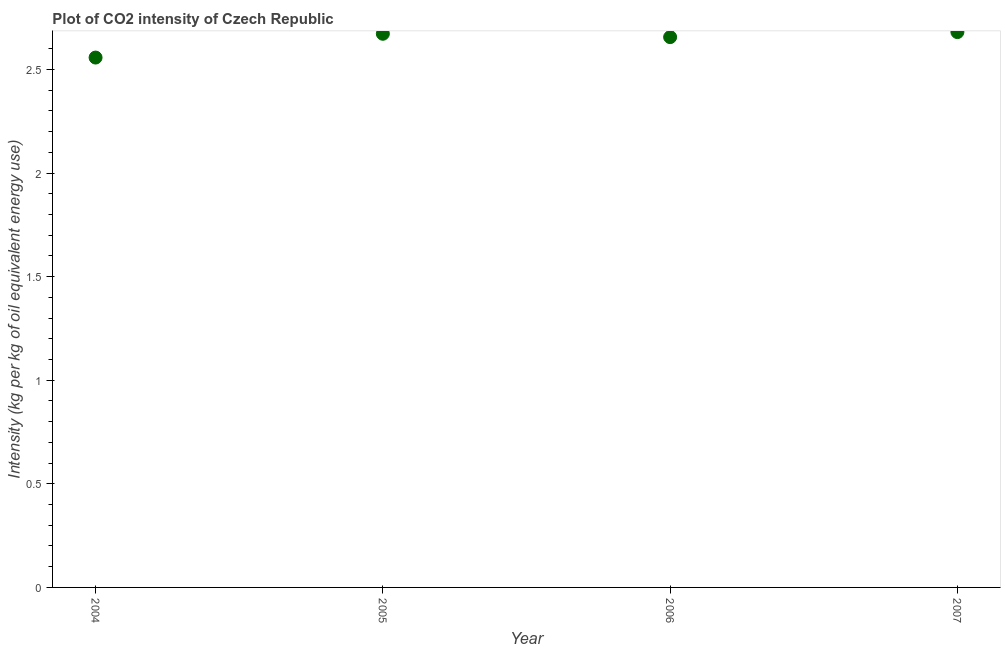What is the co2 intensity in 2004?
Your response must be concise. 2.56. Across all years, what is the maximum co2 intensity?
Your answer should be compact. 2.68. Across all years, what is the minimum co2 intensity?
Provide a short and direct response. 2.56. In which year was the co2 intensity minimum?
Give a very brief answer. 2004. What is the sum of the co2 intensity?
Give a very brief answer. 10.57. What is the difference between the co2 intensity in 2004 and 2007?
Keep it short and to the point. -0.12. What is the average co2 intensity per year?
Ensure brevity in your answer.  2.64. What is the median co2 intensity?
Provide a succinct answer. 2.66. In how many years, is the co2 intensity greater than 1.3 kg?
Your response must be concise. 4. Do a majority of the years between 2004 and 2006 (inclusive) have co2 intensity greater than 1.1 kg?
Your answer should be compact. Yes. What is the ratio of the co2 intensity in 2005 to that in 2006?
Offer a very short reply. 1.01. Is the co2 intensity in 2005 less than that in 2007?
Your answer should be very brief. Yes. What is the difference between the highest and the second highest co2 intensity?
Offer a terse response. 0.01. What is the difference between the highest and the lowest co2 intensity?
Provide a succinct answer. 0.12. How many dotlines are there?
Offer a very short reply. 1. How many years are there in the graph?
Offer a terse response. 4. What is the difference between two consecutive major ticks on the Y-axis?
Ensure brevity in your answer.  0.5. Does the graph contain grids?
Give a very brief answer. No. What is the title of the graph?
Give a very brief answer. Plot of CO2 intensity of Czech Republic. What is the label or title of the X-axis?
Provide a short and direct response. Year. What is the label or title of the Y-axis?
Your answer should be compact. Intensity (kg per kg of oil equivalent energy use). What is the Intensity (kg per kg of oil equivalent energy use) in 2004?
Your response must be concise. 2.56. What is the Intensity (kg per kg of oil equivalent energy use) in 2005?
Your answer should be very brief. 2.67. What is the Intensity (kg per kg of oil equivalent energy use) in 2006?
Offer a terse response. 2.66. What is the Intensity (kg per kg of oil equivalent energy use) in 2007?
Keep it short and to the point. 2.68. What is the difference between the Intensity (kg per kg of oil equivalent energy use) in 2004 and 2005?
Give a very brief answer. -0.11. What is the difference between the Intensity (kg per kg of oil equivalent energy use) in 2004 and 2006?
Your response must be concise. -0.1. What is the difference between the Intensity (kg per kg of oil equivalent energy use) in 2004 and 2007?
Make the answer very short. -0.12. What is the difference between the Intensity (kg per kg of oil equivalent energy use) in 2005 and 2006?
Your answer should be compact. 0.02. What is the difference between the Intensity (kg per kg of oil equivalent energy use) in 2005 and 2007?
Ensure brevity in your answer.  -0.01. What is the difference between the Intensity (kg per kg of oil equivalent energy use) in 2006 and 2007?
Provide a short and direct response. -0.02. What is the ratio of the Intensity (kg per kg of oil equivalent energy use) in 2004 to that in 2006?
Your answer should be very brief. 0.96. What is the ratio of the Intensity (kg per kg of oil equivalent energy use) in 2004 to that in 2007?
Provide a short and direct response. 0.95. What is the ratio of the Intensity (kg per kg of oil equivalent energy use) in 2005 to that in 2006?
Offer a very short reply. 1.01. What is the ratio of the Intensity (kg per kg of oil equivalent energy use) in 2005 to that in 2007?
Make the answer very short. 1. What is the ratio of the Intensity (kg per kg of oil equivalent energy use) in 2006 to that in 2007?
Provide a short and direct response. 0.99. 